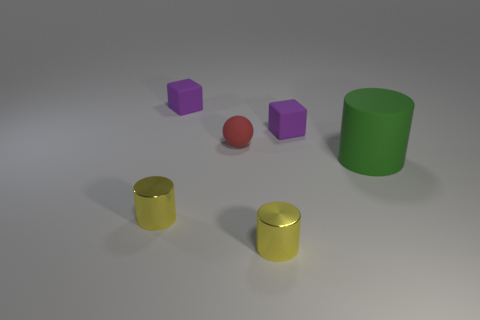The tiny rubber ball is what color?
Give a very brief answer. Red. What color is the tiny thing that is in front of the tiny sphere and on the left side of the tiny red ball?
Your answer should be very brief. Yellow. There is a ball; how many small purple objects are on the right side of it?
Make the answer very short. 1. What number of objects are big green objects or small things in front of the large green object?
Provide a short and direct response. 3. Are there any tiny matte spheres that are on the right side of the small yellow cylinder that is to the right of the red matte object?
Offer a terse response. No. The cube that is to the right of the tiny red rubber object is what color?
Your answer should be compact. Purple. Is the number of small purple rubber blocks behind the tiny red ball the same as the number of small blocks?
Provide a succinct answer. Yes. There is a rubber object that is right of the red ball and on the left side of the big green thing; what shape is it?
Ensure brevity in your answer.  Cube. What shape is the purple object right of the small purple thing on the left side of the purple thing that is right of the red thing?
Provide a succinct answer. Cube. Is the size of the green thing that is in front of the red sphere the same as the rubber cube that is to the right of the tiny red object?
Keep it short and to the point. No. 